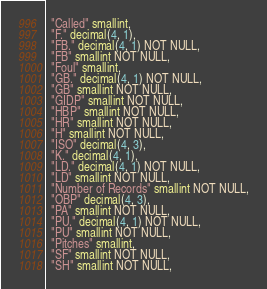Convert code to text. <code><loc_0><loc_0><loc_500><loc_500><_SQL_>  "Called" smallint,
  "F." decimal(4, 1),
  "FB." decimal(4, 1) NOT NULL,
  "FB" smallint NOT NULL,
  "Foul" smallint,
  "GB." decimal(4, 1) NOT NULL,
  "GB" smallint NOT NULL,
  "GIDP" smallint NOT NULL,
  "HBP" smallint NOT NULL,
  "HR" smallint NOT NULL,
  "H" smallint NOT NULL,
  "ISO" decimal(4, 3),
  "K." decimal(4, 1),
  "LD." decimal(4, 1) NOT NULL,
  "LD" smallint NOT NULL,
  "Number of Records" smallint NOT NULL,
  "OBP" decimal(4, 3),
  "PA" smallint NOT NULL,
  "PU." decimal(4, 1) NOT NULL,
  "PU" smallint NOT NULL,
  "Pitches" smallint,
  "SF" smallint NOT NULL,
  "SH" smallint NOT NULL,</code> 